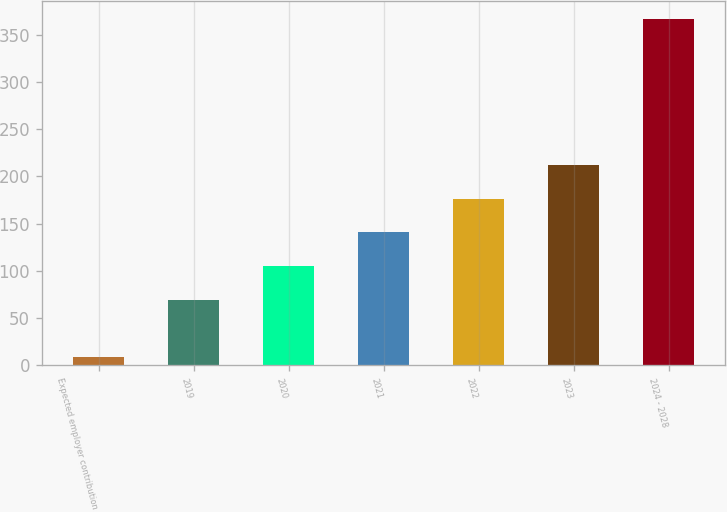Convert chart to OTSL. <chart><loc_0><loc_0><loc_500><loc_500><bar_chart><fcel>Expected employer contribution<fcel>2019<fcel>2020<fcel>2021<fcel>2022<fcel>2023<fcel>2024 - 2028<nl><fcel>9<fcel>69<fcel>104.8<fcel>140.6<fcel>176.4<fcel>212.2<fcel>367<nl></chart> 